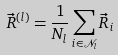<formula> <loc_0><loc_0><loc_500><loc_500>\vec { R } ^ { ( l ) } = \frac { 1 } { N _ { l } } \sum _ { i \in \mathcal { N } _ { l } } \vec { R } _ { i }</formula> 